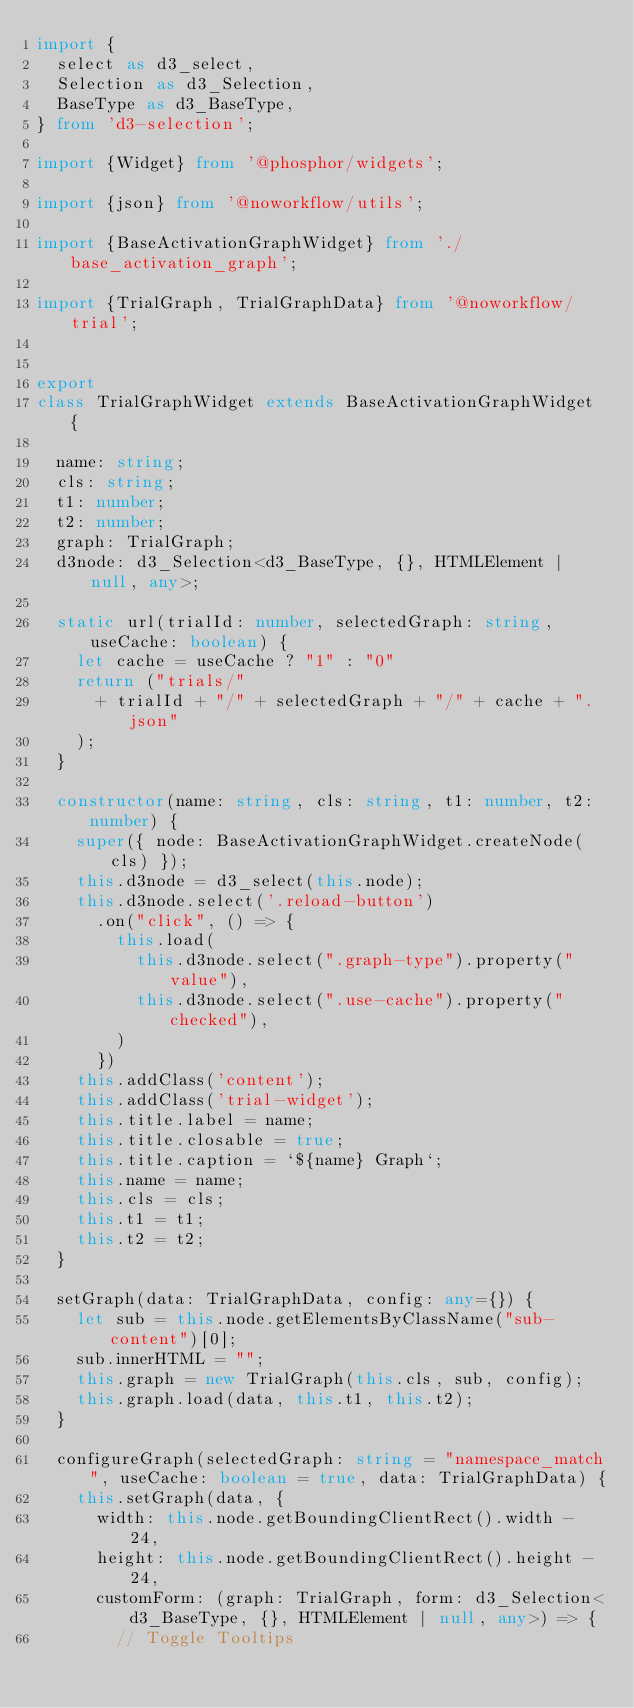<code> <loc_0><loc_0><loc_500><loc_500><_TypeScript_>import {
  select as d3_select,
  Selection as d3_Selection,
  BaseType as d3_BaseType,
} from 'd3-selection';

import {Widget} from '@phosphor/widgets';

import {json} from '@noworkflow/utils';

import {BaseActivationGraphWidget} from './base_activation_graph';

import {TrialGraph, TrialGraphData} from '@noworkflow/trial';


export
class TrialGraphWidget extends BaseActivationGraphWidget {

  name: string;
  cls: string;
  t1: number;
  t2: number;
  graph: TrialGraph;
  d3node: d3_Selection<d3_BaseType, {}, HTMLElement | null, any>;

  static url(trialId: number, selectedGraph: string, useCache: boolean) {
    let cache = useCache ? "1" : "0"
    return ("trials/"
      + trialId + "/" + selectedGraph + "/" + cache + ".json"
    );
  }

  constructor(name: string, cls: string, t1: number, t2: number) {
    super({ node: BaseActivationGraphWidget.createNode(cls) });
    this.d3node = d3_select(this.node);
    this.d3node.select('.reload-button')
      .on("click", () => {
        this.load(
          this.d3node.select(".graph-type").property("value"),
          this.d3node.select(".use-cache").property("checked"),
        )
      })
    this.addClass('content');
    this.addClass('trial-widget');
    this.title.label = name;
    this.title.closable = true;
    this.title.caption = `${name} Graph`;
    this.name = name;
    this.cls = cls;
    this.t1 = t1;
    this.t2 = t2;
  }

  setGraph(data: TrialGraphData, config: any={}) {
    let sub = this.node.getElementsByClassName("sub-content")[0];
    sub.innerHTML = "";
    this.graph = new TrialGraph(this.cls, sub, config);
    this.graph.load(data, this.t1, this.t2);
  }

  configureGraph(selectedGraph: string = "namespace_match", useCache: boolean = true, data: TrialGraphData) {
    this.setGraph(data, {
      width: this.node.getBoundingClientRect().width - 24,
      height: this.node.getBoundingClientRect().height - 24,
      customForm: (graph: TrialGraph, form: d3_Selection<d3_BaseType, {}, HTMLElement | null, any>) => {
        // Toggle Tooltips</code> 